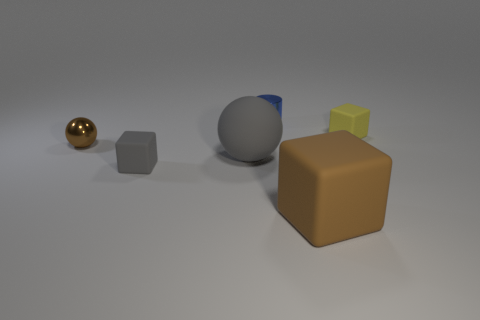What is the material of the tiny thing that is both on the right side of the tiny brown shiny thing and in front of the yellow rubber thing?
Give a very brief answer. Rubber. Is there anything else that is the same size as the blue object?
Provide a short and direct response. Yes. Is the matte ball the same color as the small metal cylinder?
Keep it short and to the point. No. What shape is the tiny object that is the same color as the large matte ball?
Offer a terse response. Cube. What number of yellow rubber things are the same shape as the large brown object?
Provide a succinct answer. 1. What is the size of the brown thing that is made of the same material as the blue object?
Provide a short and direct response. Small. Do the brown metallic ball and the gray matte block have the same size?
Make the answer very short. Yes. Is there a small cyan ball?
Keep it short and to the point. No. What size is the object that is the same color as the shiny ball?
Provide a succinct answer. Large. There is a brown metal object that is in front of the small matte object that is behind the small rubber cube in front of the yellow block; how big is it?
Provide a succinct answer. Small. 